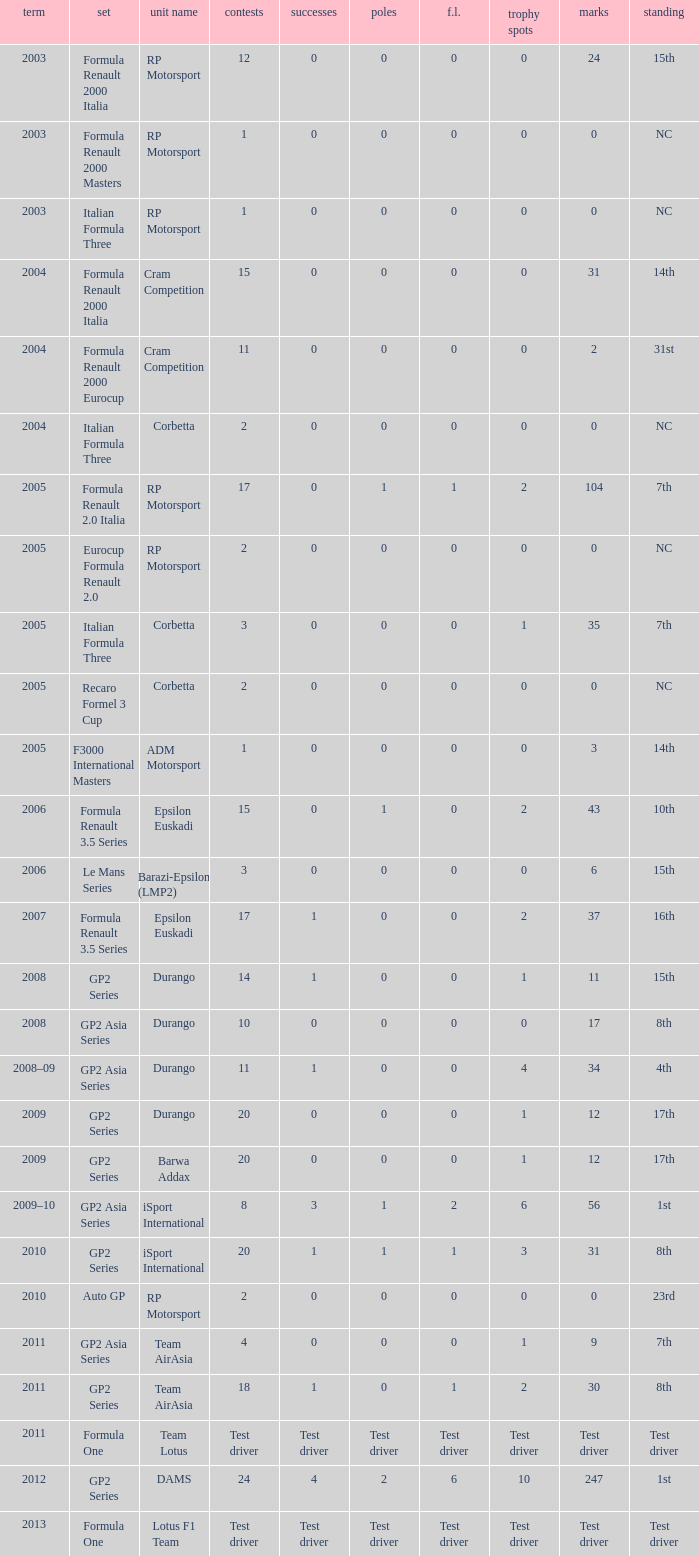What is the number of poles with 104 points? 1.0. 